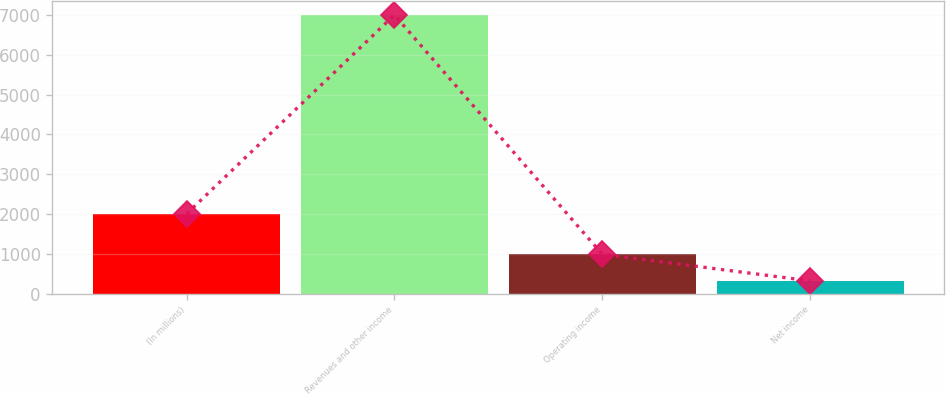Convert chart. <chart><loc_0><loc_0><loc_500><loc_500><bar_chart><fcel>(In millions)<fcel>Revenues and other income<fcel>Operating income<fcel>Net income<nl><fcel>2003<fcel>7006<fcel>987.7<fcel>319<nl></chart> 